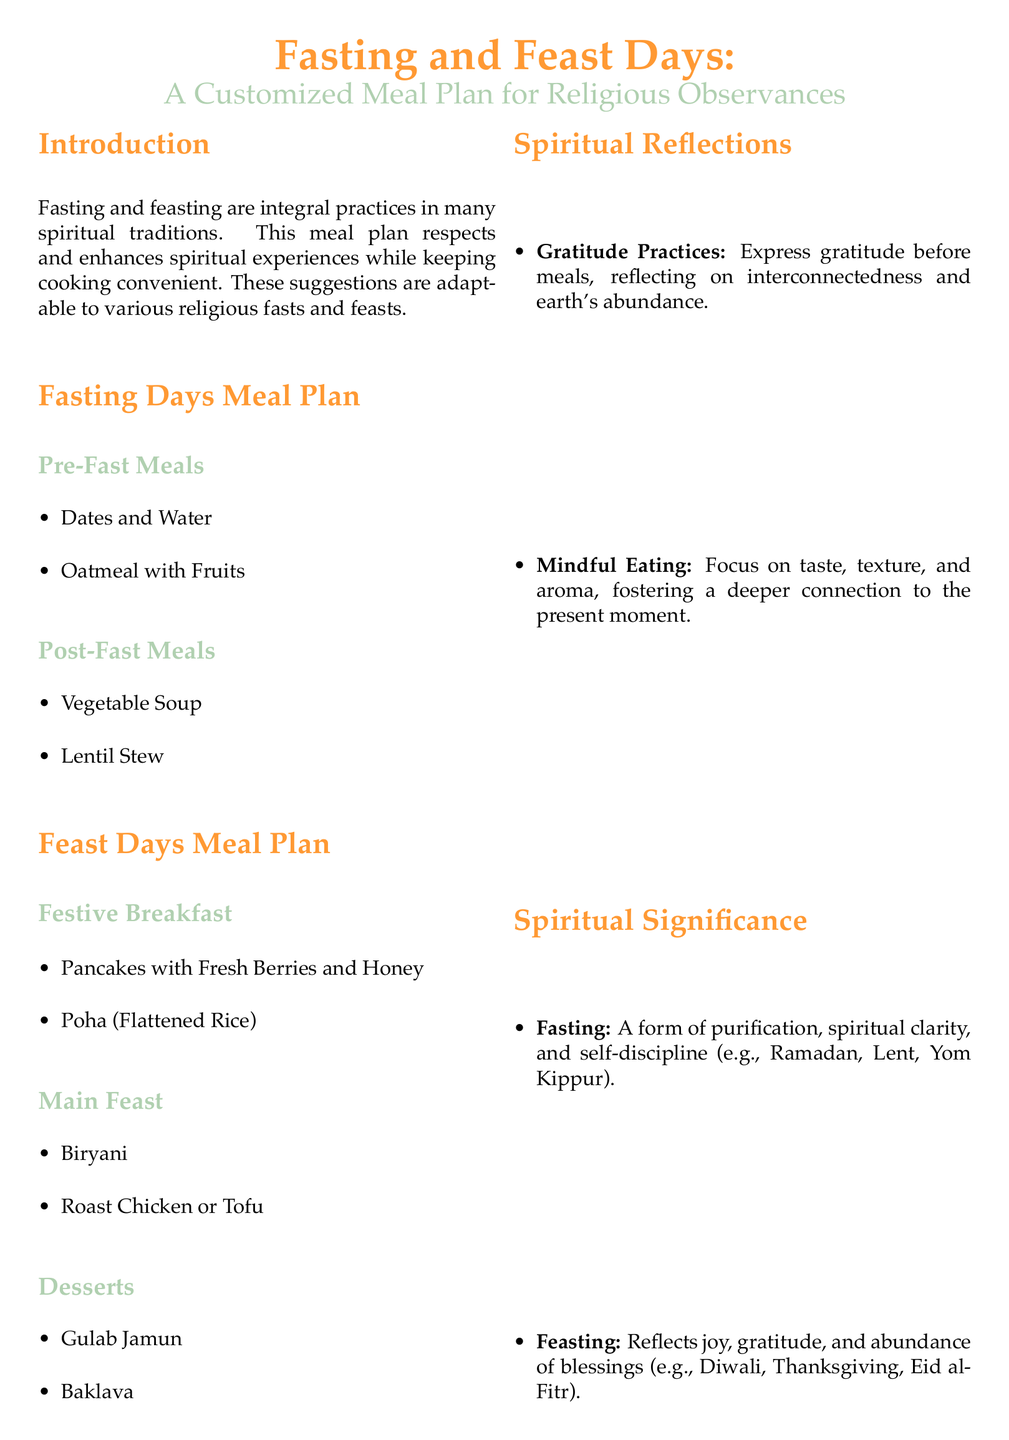What is the title of the document? The title of the document appears at the beginning and is “Fasting and Feast Days: A Customized Meal Plan for Religious Observances.”
Answer: Fasting and Feast Days: A Customized Meal Plan for Religious Observances How many meal plans are included? The document includes two main meal plans: one for fasting days and one for feast days.
Answer: Two What are the pre-fast meals suggested? The document lists “Dates and Water” and “Oatmeal with Fruits” as pre-fast meals.
Answer: Dates and Water, Oatmeal with Fruits What is one dessert mentioned in the feast days meal plan? The document mentions “Gulab Jamun” and “Baklava” as desserts for feast days.
Answer: Gulab Jamun What is the spiritual significance of fasting? According to the document, fasting is described as a form of purification, spiritual clarity, and self-discipline.
Answer: A form of purification, spiritual clarity, and self-discipline Name one gratitude practice suggested in the meal plan. The document includes “Express gratitude before meals” as a suggested gratitude practice.
Answer: Express gratitude before meals What kind of soup is suggested for post-fast meals? The document lists “Vegetable Soup” as one of the post-fast meal options.
Answer: Vegetable Soup What type of cuisine is mentioned for the main feast? The document specifies “Biryani” and “Roast Chicken or Tofu” as part of the main feast.
Answer: Biryani How does the document propose to engage in mindful eating? It suggests focusing on taste, texture, and aroma to foster a deeper connection to the present moment.
Answer: Focus on taste, texture, and aroma 